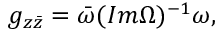<formula> <loc_0><loc_0><loc_500><loc_500>g _ { z \bar { z } } = \bar { \omega } ( I m \Omega ) ^ { - 1 } \omega ,</formula> 